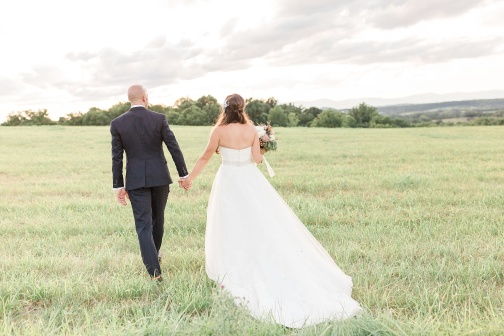Write a short poem about the image. In a sea of green, they wander far,
'Neath skies of blue and clouds so sparse.
Hand in hand, a future bright,
A love ignites, pure and light.
Steps away from times now past,
Into a journey made to last.
Fields of green, whispers of love,
Blessings beneath the skies above. 